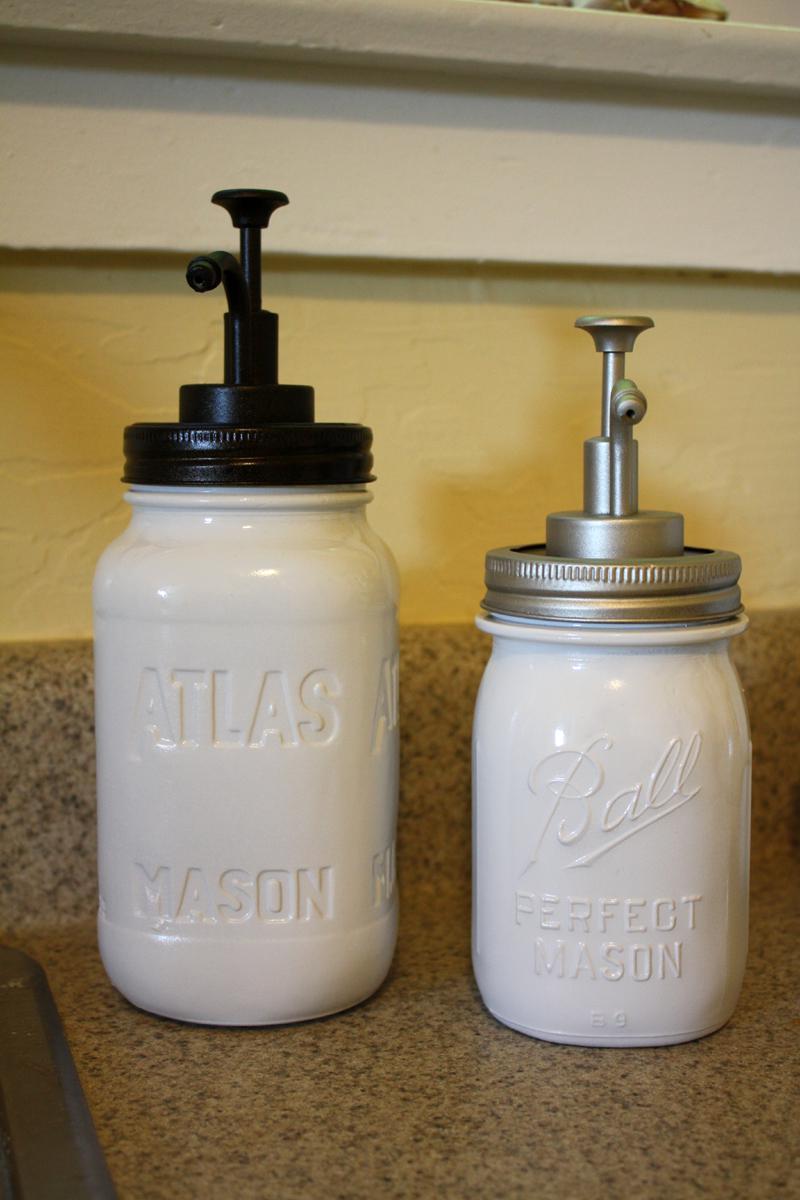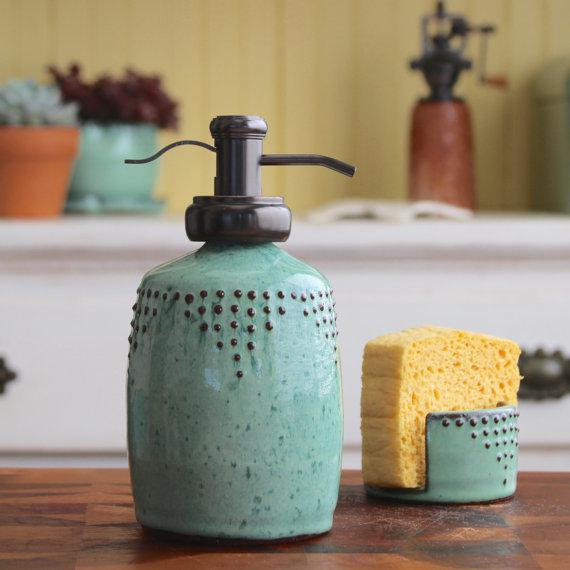The first image is the image on the left, the second image is the image on the right. For the images displayed, is the sentence "One of the images shows at least one empty glass jar with a spout on top." factually correct? Answer yes or no. No. The first image is the image on the left, the second image is the image on the right. Given the left and right images, does the statement "An image shows two opaque white dispensers side-by-side." hold true? Answer yes or no. Yes. 